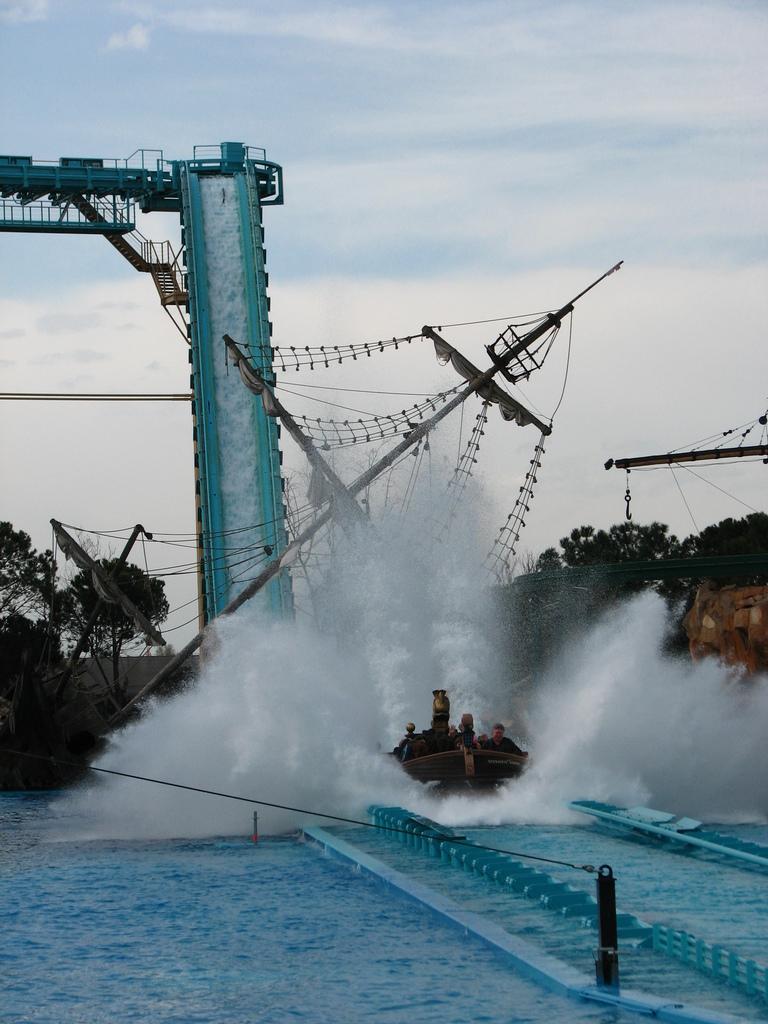In one or two sentences, can you explain what this image depicts? In the background I can observe water in the middle of the picture. In the background I can observe trees and some clouds in the sky. 